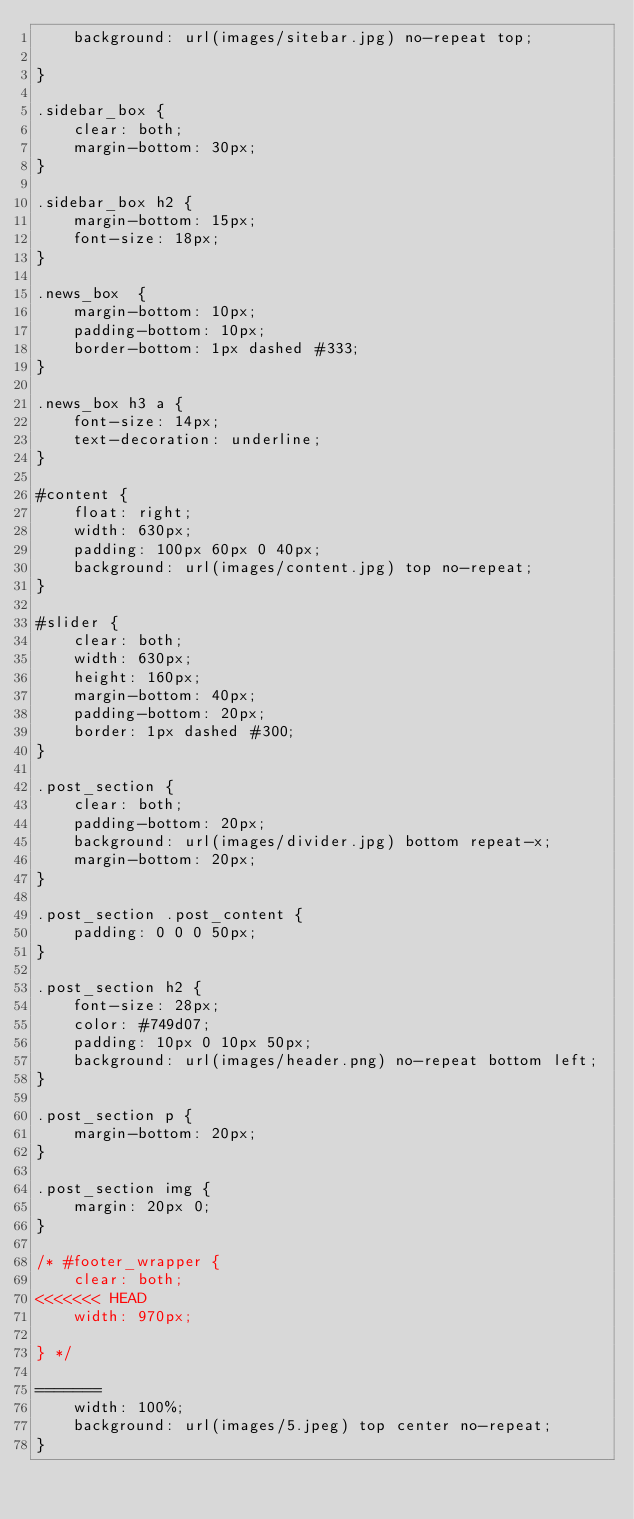Convert code to text. <code><loc_0><loc_0><loc_500><loc_500><_CSS_>	background: url(images/sitebar.jpg) no-repeat top;
	
}

.sidebar_box {
	clear: both;
	margin-bottom: 30px;
}

.sidebar_box h2 {
	margin-bottom: 15px;
	font-size: 18px;
}

.news_box  {
	margin-bottom: 10px;
	padding-bottom: 10px;
	border-bottom: 1px dashed #333;
}

.news_box h3 a {
	font-size: 14px;
	text-decoration: underline;
}

#content {
	float: right;
	width: 630px;
	padding: 100px 60px 0 40px;
	background: url(images/content.jpg) top no-repeat;
}

#slider {
	clear: both;
	width: 630px;
	height: 160px;
	margin-bottom: 40px;
	padding-bottom: 20px;
	border: 1px dashed #300;
}

.post_section {
	clear: both;
	padding-bottom: 20px;
	background: url(images/divider.jpg) bottom repeat-x;	
	margin-bottom: 20px;
}

.post_section .post_content {
	padding: 0 0 0 50px;
}

.post_section h2 {
	font-size: 28px;
	color: #749d07;
	padding: 10px 0 10px 50px;
	background: url(images/header.png) no-repeat bottom left;
}

.post_section p {
	margin-bottom: 20px;
}

.post_section img {
	margin: 20px 0;
}

/* #footer_wrapper {
	clear: both;
<<<<<<< HEAD
	width: 970px;
	
} */

=======
	width: 100%;
	background: url(images/5.jpeg) top center no-repeat;
}</code> 